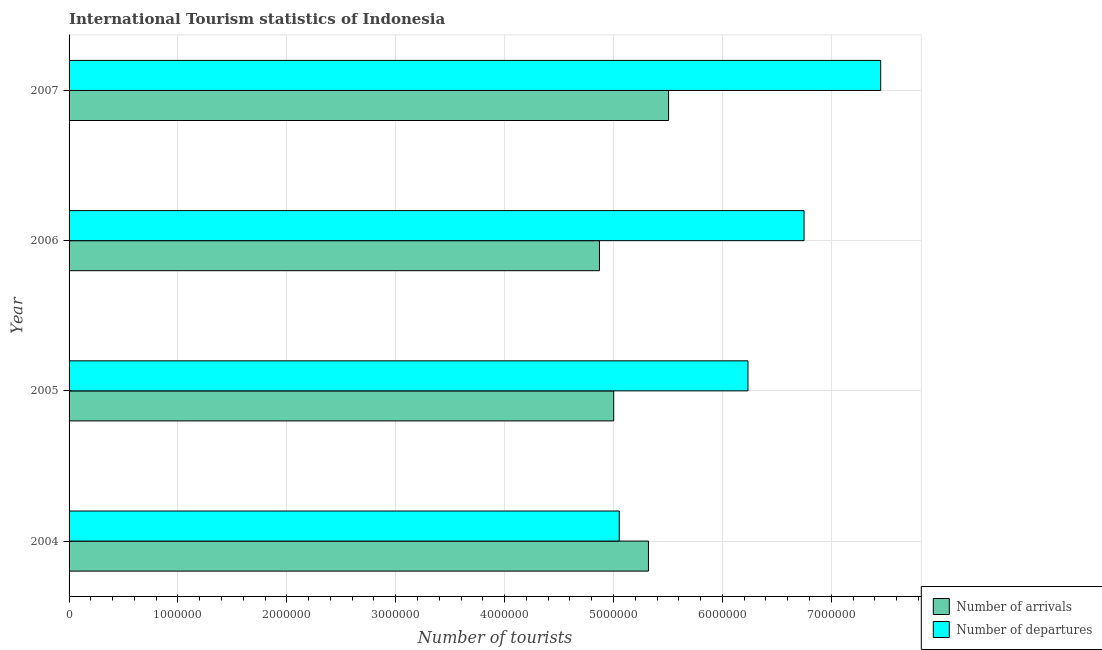Are the number of bars per tick equal to the number of legend labels?
Your answer should be very brief. Yes. Are the number of bars on each tick of the Y-axis equal?
Give a very brief answer. Yes. How many bars are there on the 4th tick from the top?
Offer a terse response. 2. What is the number of tourist departures in 2005?
Your answer should be very brief. 6.24e+06. Across all years, what is the maximum number of tourist departures?
Your response must be concise. 7.45e+06. Across all years, what is the minimum number of tourist departures?
Provide a succinct answer. 5.05e+06. What is the total number of tourist departures in the graph?
Your answer should be compact. 2.55e+07. What is the difference between the number of tourist arrivals in 2006 and that in 2007?
Your answer should be compact. -6.35e+05. What is the difference between the number of tourist departures in 2006 and the number of tourist arrivals in 2007?
Your answer should be very brief. 1.24e+06. What is the average number of tourist arrivals per year?
Your answer should be compact. 5.18e+06. In the year 2005, what is the difference between the number of tourist departures and number of tourist arrivals?
Offer a very short reply. 1.23e+06. What is the ratio of the number of tourist arrivals in 2004 to that in 2006?
Ensure brevity in your answer.  1.09. What is the difference between the highest and the second highest number of tourist departures?
Offer a very short reply. 7.04e+05. What is the difference between the highest and the lowest number of tourist arrivals?
Your answer should be compact. 6.35e+05. In how many years, is the number of tourist departures greater than the average number of tourist departures taken over all years?
Provide a short and direct response. 2. What does the 2nd bar from the top in 2007 represents?
Ensure brevity in your answer.  Number of arrivals. What does the 1st bar from the bottom in 2004 represents?
Offer a very short reply. Number of arrivals. How many bars are there?
Provide a short and direct response. 8. How many years are there in the graph?
Provide a short and direct response. 4. What is the difference between two consecutive major ticks on the X-axis?
Keep it short and to the point. 1.00e+06. Are the values on the major ticks of X-axis written in scientific E-notation?
Provide a succinct answer. No. Does the graph contain grids?
Provide a succinct answer. Yes. How many legend labels are there?
Keep it short and to the point. 2. How are the legend labels stacked?
Your answer should be very brief. Vertical. What is the title of the graph?
Your answer should be compact. International Tourism statistics of Indonesia. What is the label or title of the X-axis?
Give a very brief answer. Number of tourists. What is the Number of tourists of Number of arrivals in 2004?
Offer a terse response. 5.32e+06. What is the Number of tourists of Number of departures in 2004?
Provide a succinct answer. 5.05e+06. What is the Number of tourists in Number of arrivals in 2005?
Provide a short and direct response. 5.00e+06. What is the Number of tourists of Number of departures in 2005?
Offer a terse response. 6.24e+06. What is the Number of tourists in Number of arrivals in 2006?
Your answer should be very brief. 4.87e+06. What is the Number of tourists in Number of departures in 2006?
Offer a very short reply. 6.75e+06. What is the Number of tourists of Number of arrivals in 2007?
Make the answer very short. 5.51e+06. What is the Number of tourists of Number of departures in 2007?
Your answer should be very brief. 7.45e+06. Across all years, what is the maximum Number of tourists in Number of arrivals?
Offer a terse response. 5.51e+06. Across all years, what is the maximum Number of tourists in Number of departures?
Your response must be concise. 7.45e+06. Across all years, what is the minimum Number of tourists of Number of arrivals?
Make the answer very short. 4.87e+06. Across all years, what is the minimum Number of tourists in Number of departures?
Provide a succinct answer. 5.05e+06. What is the total Number of tourists in Number of arrivals in the graph?
Ensure brevity in your answer.  2.07e+07. What is the total Number of tourists in Number of departures in the graph?
Offer a terse response. 2.55e+07. What is the difference between the Number of tourists of Number of arrivals in 2004 and that in 2005?
Provide a short and direct response. 3.19e+05. What is the difference between the Number of tourists of Number of departures in 2004 and that in 2005?
Keep it short and to the point. -1.18e+06. What is the difference between the Number of tourists in Number of arrivals in 2004 and that in 2006?
Your answer should be very brief. 4.50e+05. What is the difference between the Number of tourists of Number of departures in 2004 and that in 2006?
Offer a terse response. -1.70e+06. What is the difference between the Number of tourists of Number of arrivals in 2004 and that in 2007?
Ensure brevity in your answer.  -1.85e+05. What is the difference between the Number of tourists of Number of departures in 2004 and that in 2007?
Your answer should be very brief. -2.40e+06. What is the difference between the Number of tourists in Number of arrivals in 2005 and that in 2006?
Offer a terse response. 1.31e+05. What is the difference between the Number of tourists of Number of departures in 2005 and that in 2006?
Keep it short and to the point. -5.15e+05. What is the difference between the Number of tourists in Number of arrivals in 2005 and that in 2007?
Your answer should be compact. -5.04e+05. What is the difference between the Number of tourists in Number of departures in 2005 and that in 2007?
Your answer should be very brief. -1.22e+06. What is the difference between the Number of tourists of Number of arrivals in 2006 and that in 2007?
Provide a short and direct response. -6.35e+05. What is the difference between the Number of tourists of Number of departures in 2006 and that in 2007?
Provide a short and direct response. -7.04e+05. What is the difference between the Number of tourists of Number of arrivals in 2004 and the Number of tourists of Number of departures in 2005?
Make the answer very short. -9.14e+05. What is the difference between the Number of tourists of Number of arrivals in 2004 and the Number of tourists of Number of departures in 2006?
Offer a very short reply. -1.43e+06. What is the difference between the Number of tourists in Number of arrivals in 2004 and the Number of tourists in Number of departures in 2007?
Your answer should be compact. -2.13e+06. What is the difference between the Number of tourists of Number of arrivals in 2005 and the Number of tourists of Number of departures in 2006?
Your response must be concise. -1.75e+06. What is the difference between the Number of tourists in Number of arrivals in 2005 and the Number of tourists in Number of departures in 2007?
Ensure brevity in your answer.  -2.45e+06. What is the difference between the Number of tourists in Number of arrivals in 2006 and the Number of tourists in Number of departures in 2007?
Provide a short and direct response. -2.58e+06. What is the average Number of tourists of Number of arrivals per year?
Your answer should be very brief. 5.18e+06. What is the average Number of tourists of Number of departures per year?
Your answer should be very brief. 6.37e+06. In the year 2004, what is the difference between the Number of tourists of Number of arrivals and Number of tourists of Number of departures?
Provide a short and direct response. 2.68e+05. In the year 2005, what is the difference between the Number of tourists of Number of arrivals and Number of tourists of Number of departures?
Your response must be concise. -1.23e+06. In the year 2006, what is the difference between the Number of tourists of Number of arrivals and Number of tourists of Number of departures?
Your answer should be very brief. -1.88e+06. In the year 2007, what is the difference between the Number of tourists in Number of arrivals and Number of tourists in Number of departures?
Keep it short and to the point. -1.95e+06. What is the ratio of the Number of tourists of Number of arrivals in 2004 to that in 2005?
Offer a very short reply. 1.06. What is the ratio of the Number of tourists in Number of departures in 2004 to that in 2005?
Provide a short and direct response. 0.81. What is the ratio of the Number of tourists of Number of arrivals in 2004 to that in 2006?
Ensure brevity in your answer.  1.09. What is the ratio of the Number of tourists in Number of departures in 2004 to that in 2006?
Give a very brief answer. 0.75. What is the ratio of the Number of tourists of Number of arrivals in 2004 to that in 2007?
Offer a terse response. 0.97. What is the ratio of the Number of tourists in Number of departures in 2004 to that in 2007?
Ensure brevity in your answer.  0.68. What is the ratio of the Number of tourists in Number of arrivals in 2005 to that in 2006?
Your answer should be compact. 1.03. What is the ratio of the Number of tourists of Number of departures in 2005 to that in 2006?
Your answer should be very brief. 0.92. What is the ratio of the Number of tourists of Number of arrivals in 2005 to that in 2007?
Ensure brevity in your answer.  0.91. What is the ratio of the Number of tourists in Number of departures in 2005 to that in 2007?
Your answer should be compact. 0.84. What is the ratio of the Number of tourists in Number of arrivals in 2006 to that in 2007?
Ensure brevity in your answer.  0.88. What is the ratio of the Number of tourists of Number of departures in 2006 to that in 2007?
Make the answer very short. 0.91. What is the difference between the highest and the second highest Number of tourists in Number of arrivals?
Give a very brief answer. 1.85e+05. What is the difference between the highest and the second highest Number of tourists in Number of departures?
Offer a terse response. 7.04e+05. What is the difference between the highest and the lowest Number of tourists of Number of arrivals?
Keep it short and to the point. 6.35e+05. What is the difference between the highest and the lowest Number of tourists of Number of departures?
Provide a succinct answer. 2.40e+06. 